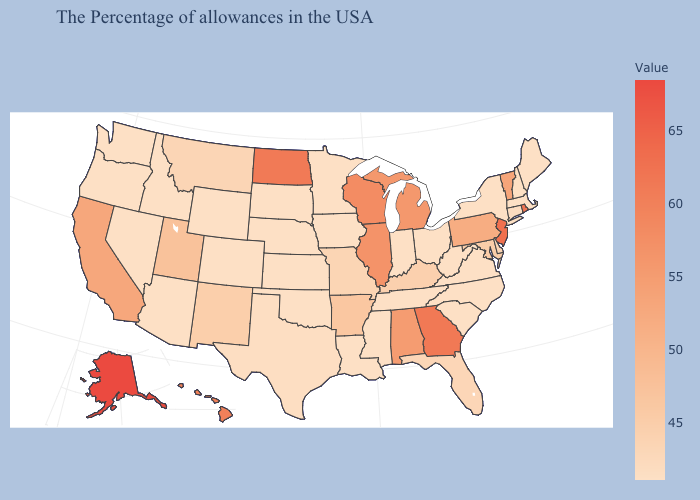Among the states that border South Carolina , does North Carolina have the highest value?
Quick response, please. No. Which states hav the highest value in the South?
Answer briefly. Georgia. Which states have the lowest value in the Northeast?
Answer briefly. Maine, Massachusetts, New York. Does Maine have the highest value in the Northeast?
Concise answer only. No. Does the map have missing data?
Give a very brief answer. No. Does New Mexico have a higher value than Vermont?
Concise answer only. No. 